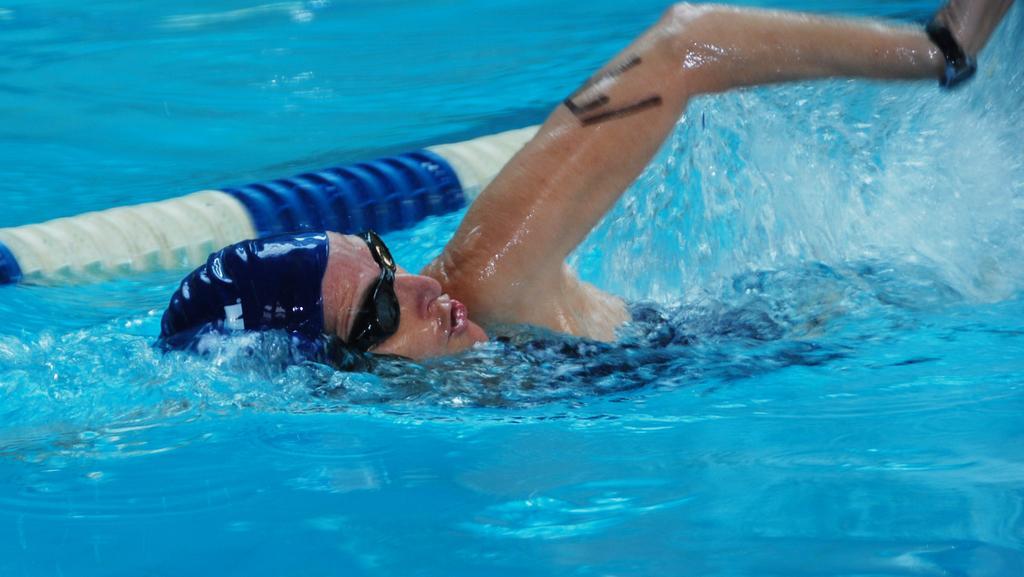How would you summarize this image in a sentence or two? In the center of the image there is a person swimming in water. There is a barrier. 